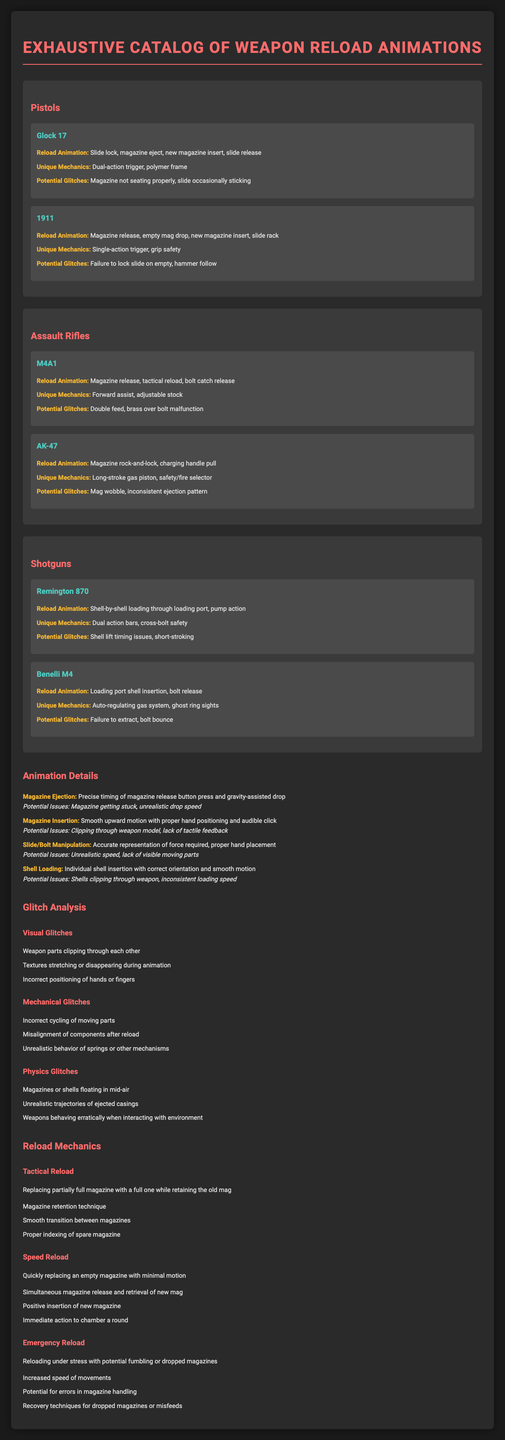What is the reload animation for the Glock 17? The reload animation for Glock 17 includes slide lock, magazine eject, new magazine insert, and slide release.
Answer: Slide lock, magazine eject, new magazine insert, slide release What unique mechanic does the AK-47 have? The unique mechanic of the AK-47 is its long-stroke gas piston and safety/fire selector.
Answer: Long-stroke gas piston, safety/fire selector Which shotgun has a potential glitch related to shell lift timing issues? The Remington 870 has a potential glitch related to shell lift timing issues.
Answer: Remington 870 What is a Tactical Reload? A Tactical Reload is replacing a partially full magazine with a full one while retaining the old magazine.
Answer: Replacing partially full magazine with a full one while retaining the old mag List one potential issue linked to Shell Loading animation. One potential issue linked to Shell Loading animation is shells clipping through the weapon.
Answer: Shells clipping through weapon What type of glitch involves magazines or shells floating in mid-air? That type of glitch is categorized as a physics glitch.
Answer: Physics glitch 